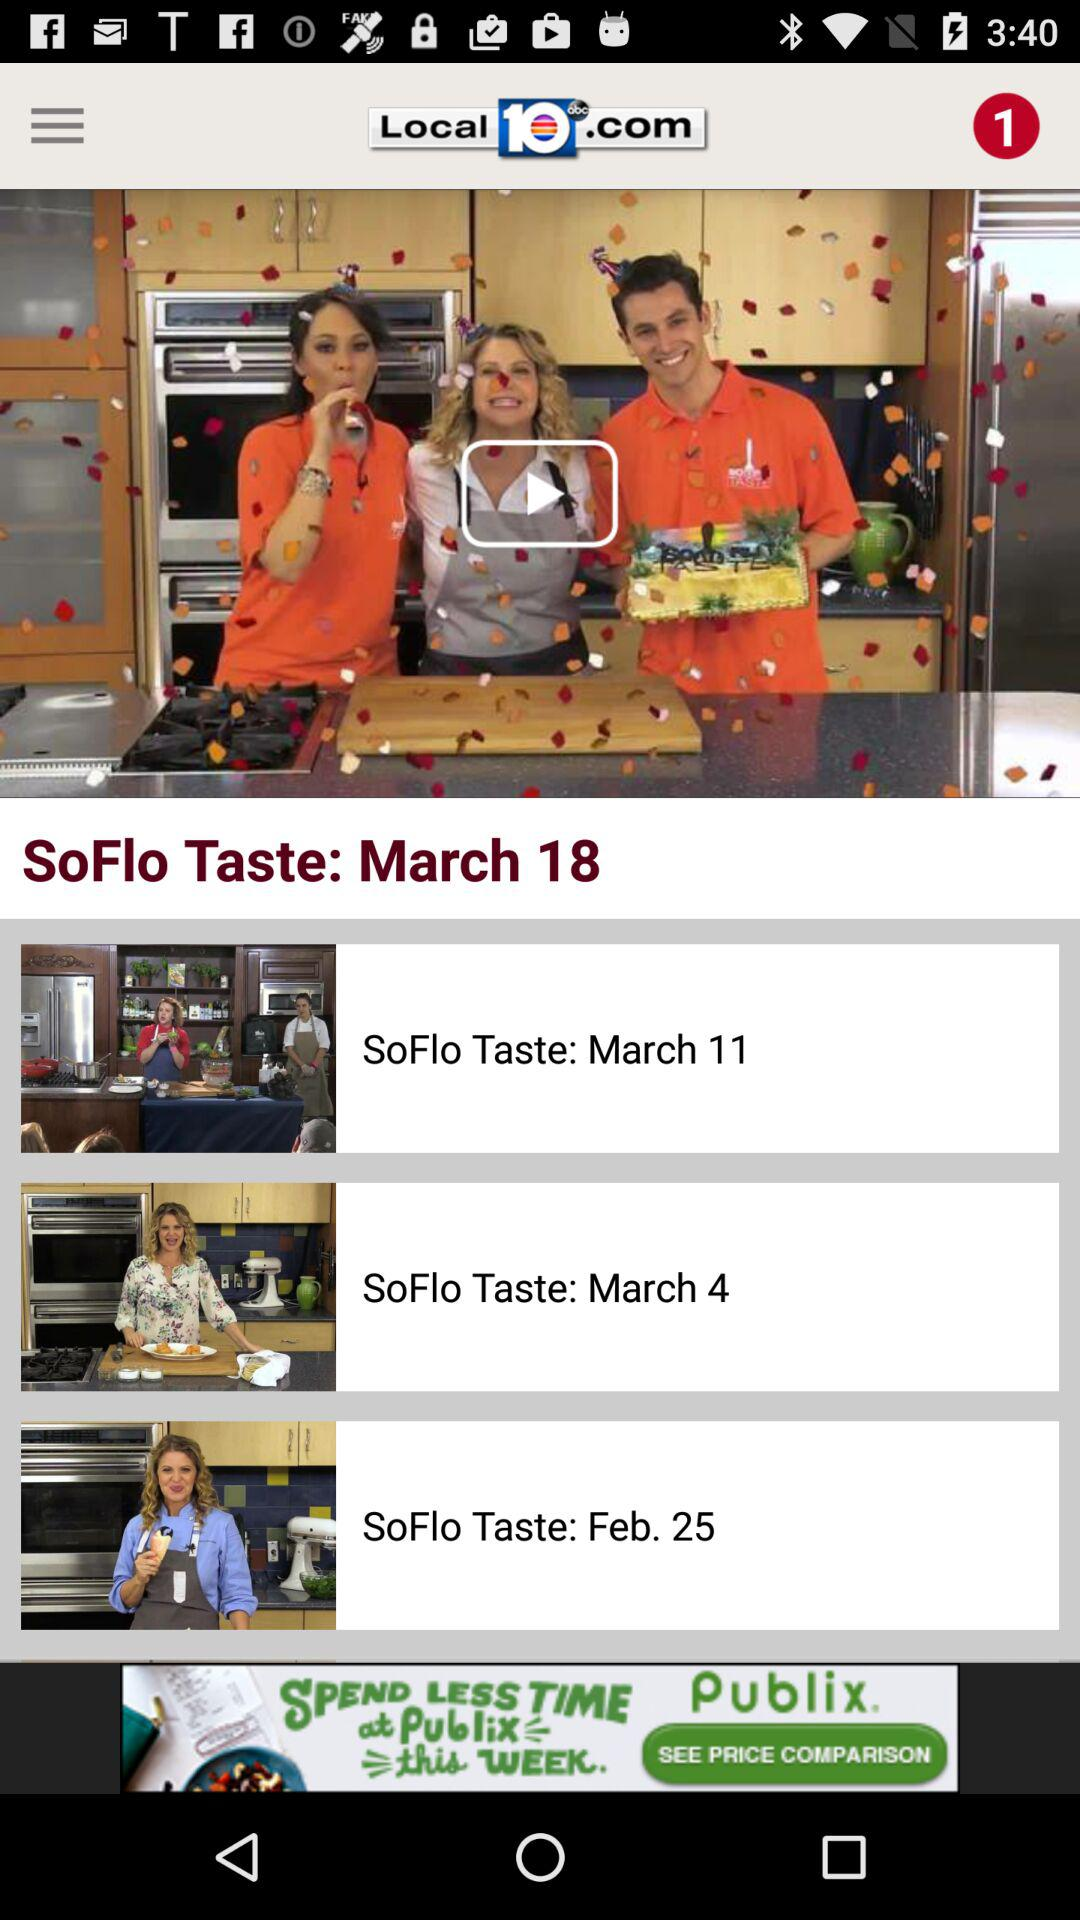How long is the video "SoFlo Taste: March 18"?
When the provided information is insufficient, respond with <no answer>. <no answer> 